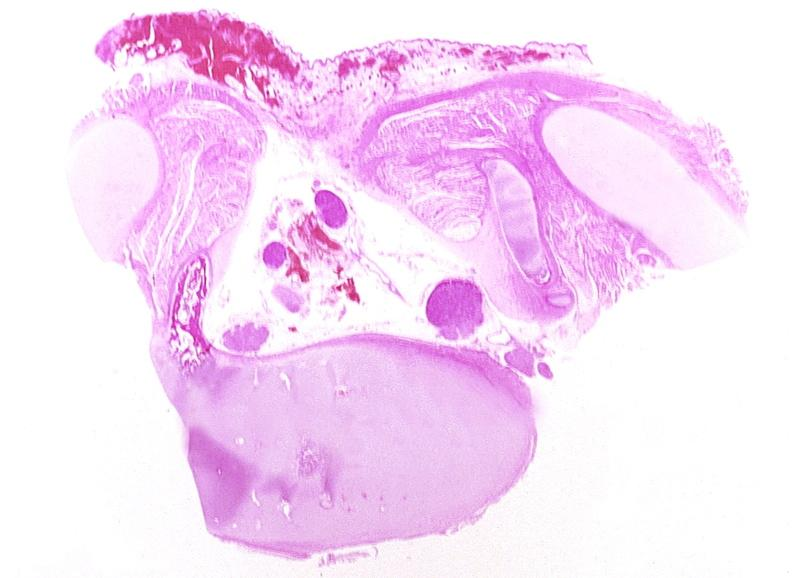what is present?
Answer the question using a single word or phrase. Nervous 